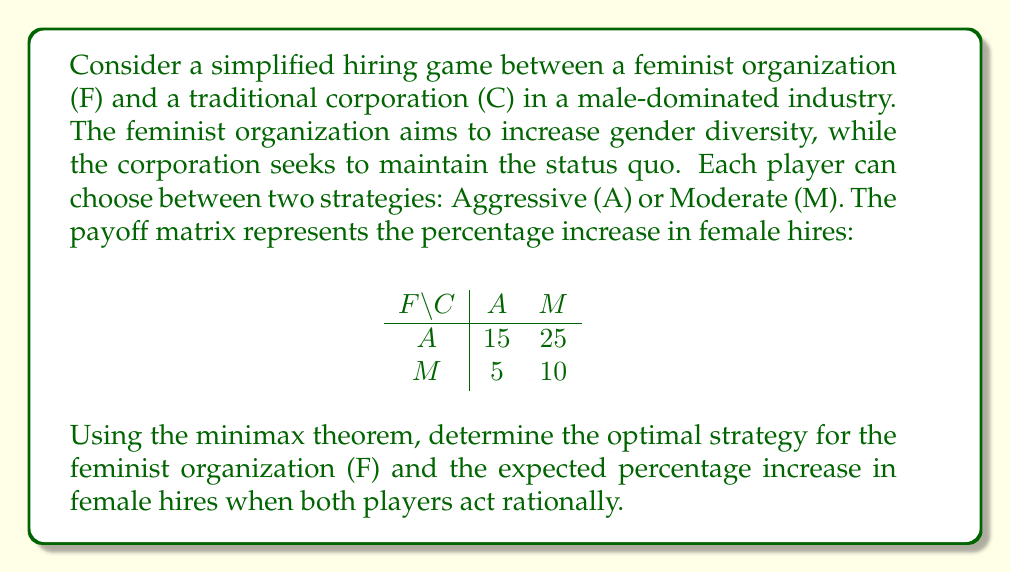Can you solve this math problem? To solve this problem using the minimax theorem, we follow these steps:

1) First, we identify the minimax and maximin values:

   For F (row player):
   - If C plays A: max(15, 5) = 15
   - If C plays M: max(25, 10) = 25
   Maximin for F = min(15, 25) = 15

   For C (column player):
   - If F plays A: min(15, 25) = 15
   - If F plays M: min(5, 10) = 5
   Minimax for C = max(15, 5) = 15

2) Since the minimax and maximin values are equal (both 15), there is a pure strategy equilibrium.

3) The optimal strategy for F is to always play A (Aggressive).

4) To calculate the expected percentage increase in female hires, we need to consider C's best response:
   - If F plays A, C's best response is A (minimizing F's gain to 15%)

5) Therefore, the expected percentage increase in female hires is 15%.

This result illustrates how even in a simplified model, gender bias in hiring practices can be challenged through strategic action, albeit with limited gains in a resistant environment.
Answer: The optimal strategy for the feminist organization (F) is to always play Aggressive (A). The expected percentage increase in female hires when both players act rationally is 15%. 